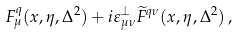<formula> <loc_0><loc_0><loc_500><loc_500>F ^ { q } _ { \mu } ( x , \eta , \Delta ^ { 2 } ) + i \varepsilon _ { \mu \nu } ^ { \perp } \widetilde { F } ^ { q \nu } ( x , \eta , \Delta ^ { 2 } ) \, ,</formula> 